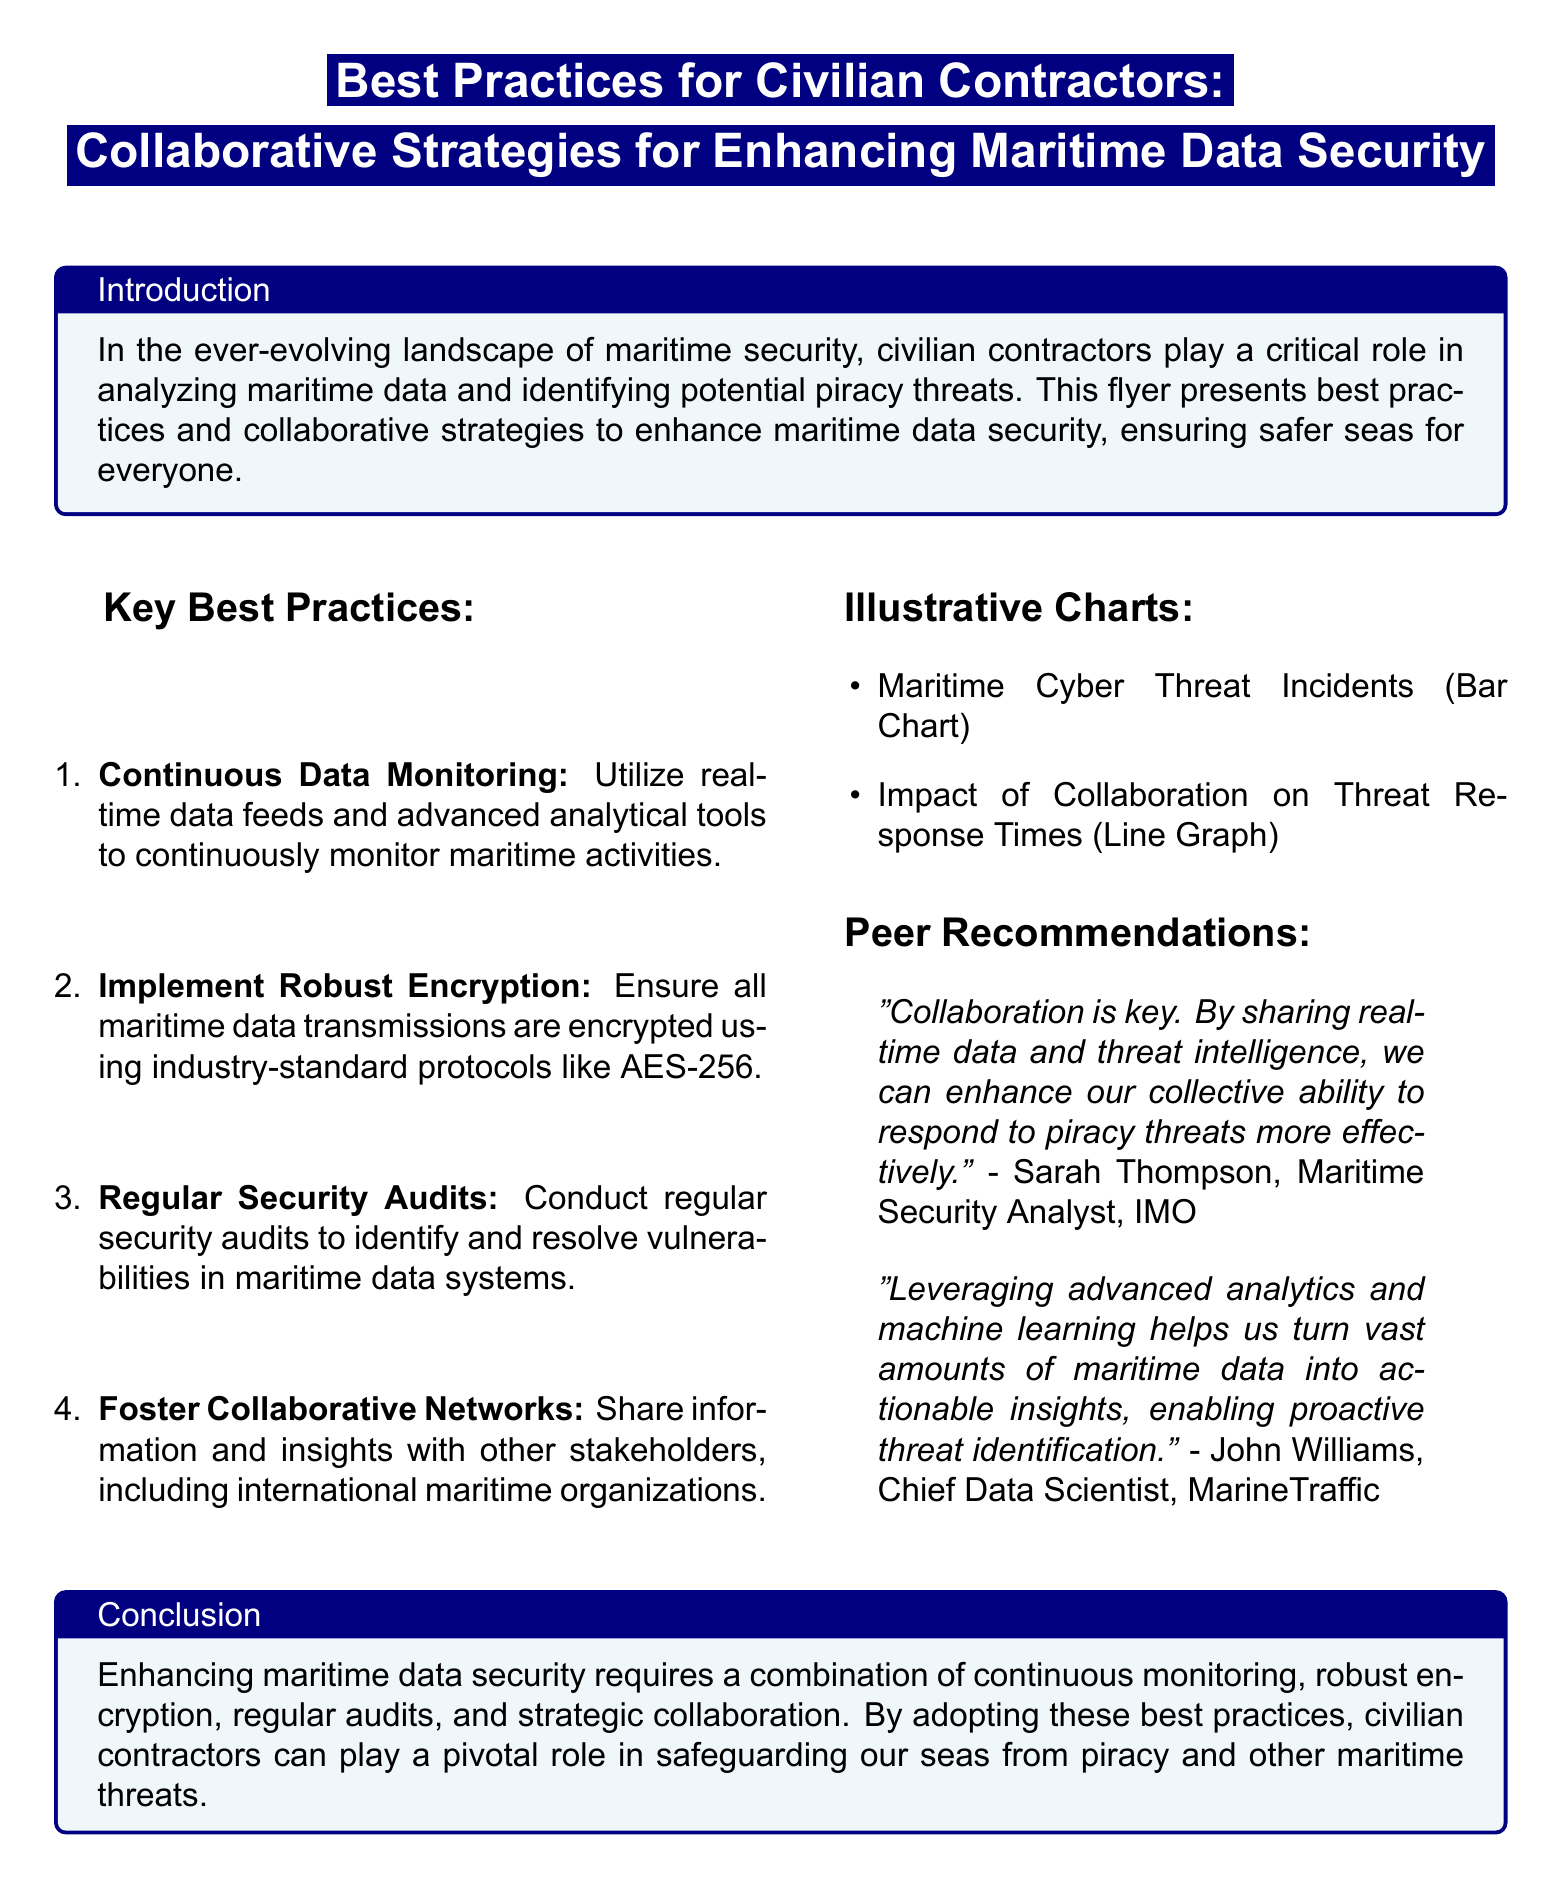What are the key best practices mentioned? The key best practices are listed in the document under "Key Best Practices", which include Continuous Data Monitoring, Implement Robust Encryption, Regular Security Audits, and Foster Collaborative Networks.
Answer: Continuous Data Monitoring, Implement Robust Encryption, Regular Security Audits, Foster Collaborative Networks Who is the author of the quote on collaboration? The document includes a quote about collaboration from Sarah Thompson, identified as a Maritime Security Analyst at the IMO.
Answer: Sarah Thompson What should be used for maritime data encryption? The document specifies the use of industry-standard protocols like AES-256 for encrypting maritime data transmissions.
Answer: AES-256 What is the main role of civilian contractors according to the document? The document states that civilian contractors play a critical role in analyzing maritime data and identifying potential piracy threats.
Answer: Analyzing maritime data What type of chart is mentioned in the document? The document references a Bar Chart that represents Maritime Cyber Threat Incidents and a Line Graph showing the Impact of Collaboration on Threat Response Times.
Answer: Bar Chart and Line Graph What is the conclusion's focus in the document? The conclusion highlights that enhancing maritime data security requires a combination of continuous monitoring, robust encryption, regular audits, and strategic collaboration.
Answer: Continuous monitoring, robust encryption, regular audits, strategic collaboration 